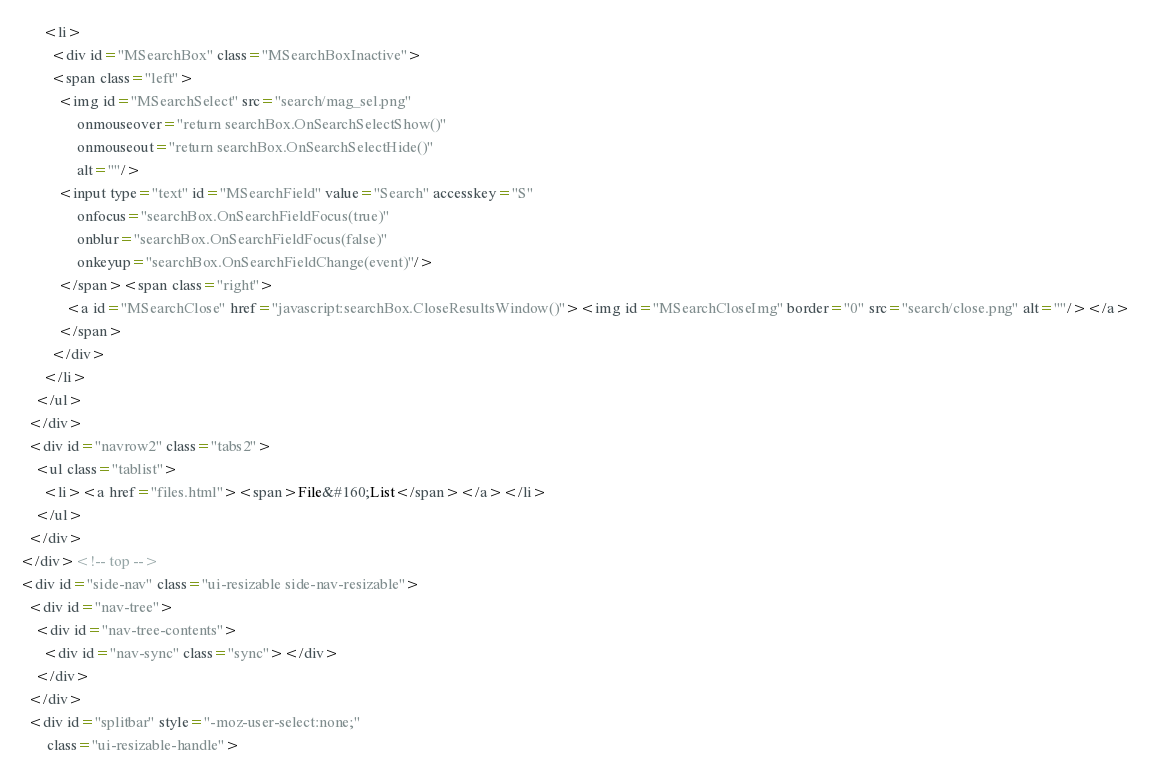Convert code to text. <code><loc_0><loc_0><loc_500><loc_500><_HTML_>      <li>
        <div id="MSearchBox" class="MSearchBoxInactive">
        <span class="left">
          <img id="MSearchSelect" src="search/mag_sel.png"
               onmouseover="return searchBox.OnSearchSelectShow()"
               onmouseout="return searchBox.OnSearchSelectHide()"
               alt=""/>
          <input type="text" id="MSearchField" value="Search" accesskey="S"
               onfocus="searchBox.OnSearchFieldFocus(true)" 
               onblur="searchBox.OnSearchFieldFocus(false)" 
               onkeyup="searchBox.OnSearchFieldChange(event)"/>
          </span><span class="right">
            <a id="MSearchClose" href="javascript:searchBox.CloseResultsWindow()"><img id="MSearchCloseImg" border="0" src="search/close.png" alt=""/></a>
          </span>
        </div>
      </li>
    </ul>
  </div>
  <div id="navrow2" class="tabs2">
    <ul class="tablist">
      <li><a href="files.html"><span>File&#160;List</span></a></li>
    </ul>
  </div>
</div><!-- top -->
<div id="side-nav" class="ui-resizable side-nav-resizable">
  <div id="nav-tree">
    <div id="nav-tree-contents">
      <div id="nav-sync" class="sync"></div>
    </div>
  </div>
  <div id="splitbar" style="-moz-user-select:none;" 
       class="ui-resizable-handle"></code> 